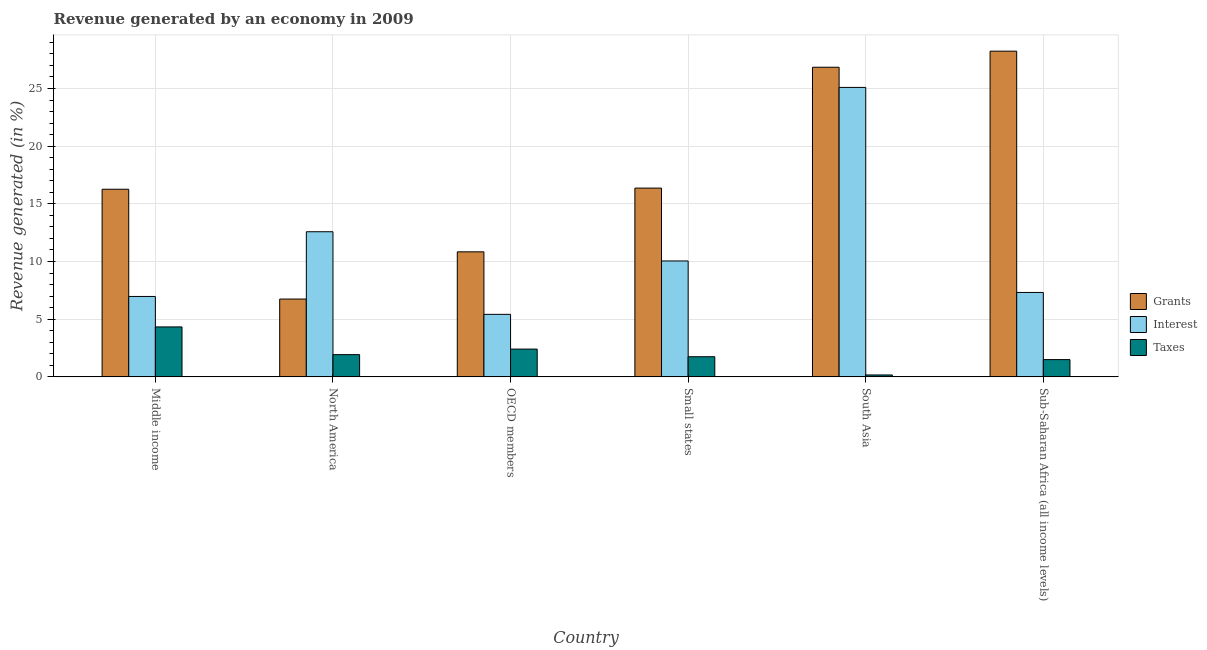How many different coloured bars are there?
Your response must be concise. 3. How many groups of bars are there?
Provide a short and direct response. 6. Are the number of bars on each tick of the X-axis equal?
Make the answer very short. Yes. What is the percentage of revenue generated by grants in Sub-Saharan Africa (all income levels)?
Your answer should be very brief. 28.24. Across all countries, what is the maximum percentage of revenue generated by taxes?
Offer a terse response. 4.33. Across all countries, what is the minimum percentage of revenue generated by grants?
Keep it short and to the point. 6.75. What is the total percentage of revenue generated by taxes in the graph?
Your response must be concise. 12.08. What is the difference between the percentage of revenue generated by grants in South Asia and that in Sub-Saharan Africa (all income levels)?
Ensure brevity in your answer.  -1.39. What is the difference between the percentage of revenue generated by grants in OECD members and the percentage of revenue generated by interest in South Asia?
Your answer should be very brief. -14.26. What is the average percentage of revenue generated by interest per country?
Your answer should be very brief. 11.24. What is the difference between the percentage of revenue generated by taxes and percentage of revenue generated by interest in North America?
Provide a succinct answer. -10.65. What is the ratio of the percentage of revenue generated by taxes in Middle income to that in Sub-Saharan Africa (all income levels)?
Offer a very short reply. 2.89. Is the difference between the percentage of revenue generated by grants in Small states and Sub-Saharan Africa (all income levels) greater than the difference between the percentage of revenue generated by interest in Small states and Sub-Saharan Africa (all income levels)?
Your answer should be very brief. No. What is the difference between the highest and the second highest percentage of revenue generated by interest?
Your answer should be compact. 12.51. What is the difference between the highest and the lowest percentage of revenue generated by grants?
Your answer should be compact. 21.49. In how many countries, is the percentage of revenue generated by taxes greater than the average percentage of revenue generated by taxes taken over all countries?
Keep it short and to the point. 2. Is the sum of the percentage of revenue generated by taxes in Small states and South Asia greater than the maximum percentage of revenue generated by grants across all countries?
Give a very brief answer. No. What does the 3rd bar from the left in Sub-Saharan Africa (all income levels) represents?
Your response must be concise. Taxes. What does the 3rd bar from the right in Middle income represents?
Give a very brief answer. Grants. How many bars are there?
Your answer should be very brief. 18. Are all the bars in the graph horizontal?
Provide a short and direct response. No. What is the difference between two consecutive major ticks on the Y-axis?
Offer a very short reply. 5. Does the graph contain any zero values?
Offer a very short reply. No. How many legend labels are there?
Offer a terse response. 3. How are the legend labels stacked?
Your answer should be very brief. Vertical. What is the title of the graph?
Ensure brevity in your answer.  Revenue generated by an economy in 2009. What is the label or title of the X-axis?
Keep it short and to the point. Country. What is the label or title of the Y-axis?
Your response must be concise. Revenue generated (in %). What is the Revenue generated (in %) of Grants in Middle income?
Offer a terse response. 16.27. What is the Revenue generated (in %) in Interest in Middle income?
Your answer should be compact. 6.97. What is the Revenue generated (in %) of Taxes in Middle income?
Offer a terse response. 4.33. What is the Revenue generated (in %) of Grants in North America?
Your answer should be very brief. 6.75. What is the Revenue generated (in %) in Interest in North America?
Offer a very short reply. 12.58. What is the Revenue generated (in %) in Taxes in North America?
Keep it short and to the point. 1.93. What is the Revenue generated (in %) of Grants in OECD members?
Your answer should be very brief. 10.84. What is the Revenue generated (in %) in Interest in OECD members?
Give a very brief answer. 5.42. What is the Revenue generated (in %) in Taxes in OECD members?
Offer a terse response. 2.41. What is the Revenue generated (in %) in Grants in Small states?
Your response must be concise. 16.37. What is the Revenue generated (in %) of Interest in Small states?
Your response must be concise. 10.05. What is the Revenue generated (in %) in Taxes in Small states?
Keep it short and to the point. 1.75. What is the Revenue generated (in %) of Grants in South Asia?
Provide a short and direct response. 26.84. What is the Revenue generated (in %) of Interest in South Asia?
Offer a very short reply. 25.1. What is the Revenue generated (in %) in Taxes in South Asia?
Your answer should be very brief. 0.17. What is the Revenue generated (in %) in Grants in Sub-Saharan Africa (all income levels)?
Offer a very short reply. 28.24. What is the Revenue generated (in %) in Interest in Sub-Saharan Africa (all income levels)?
Offer a very short reply. 7.32. What is the Revenue generated (in %) in Taxes in Sub-Saharan Africa (all income levels)?
Give a very brief answer. 1.5. Across all countries, what is the maximum Revenue generated (in %) in Grants?
Your answer should be very brief. 28.24. Across all countries, what is the maximum Revenue generated (in %) of Interest?
Offer a very short reply. 25.1. Across all countries, what is the maximum Revenue generated (in %) of Taxes?
Your answer should be very brief. 4.33. Across all countries, what is the minimum Revenue generated (in %) in Grants?
Make the answer very short. 6.75. Across all countries, what is the minimum Revenue generated (in %) of Interest?
Provide a short and direct response. 5.42. Across all countries, what is the minimum Revenue generated (in %) of Taxes?
Offer a terse response. 0.17. What is the total Revenue generated (in %) of Grants in the graph?
Offer a very short reply. 105.3. What is the total Revenue generated (in %) in Interest in the graph?
Make the answer very short. 67.44. What is the total Revenue generated (in %) in Taxes in the graph?
Ensure brevity in your answer.  12.08. What is the difference between the Revenue generated (in %) of Grants in Middle income and that in North America?
Your answer should be compact. 9.52. What is the difference between the Revenue generated (in %) in Interest in Middle income and that in North America?
Offer a very short reply. -5.61. What is the difference between the Revenue generated (in %) of Taxes in Middle income and that in North America?
Ensure brevity in your answer.  2.4. What is the difference between the Revenue generated (in %) of Grants in Middle income and that in OECD members?
Provide a short and direct response. 5.43. What is the difference between the Revenue generated (in %) in Interest in Middle income and that in OECD members?
Your answer should be very brief. 1.55. What is the difference between the Revenue generated (in %) in Taxes in Middle income and that in OECD members?
Your answer should be compact. 1.92. What is the difference between the Revenue generated (in %) of Grants in Middle income and that in Small states?
Offer a terse response. -0.1. What is the difference between the Revenue generated (in %) of Interest in Middle income and that in Small states?
Your answer should be compact. -3.08. What is the difference between the Revenue generated (in %) in Taxes in Middle income and that in Small states?
Provide a succinct answer. 2.58. What is the difference between the Revenue generated (in %) in Grants in Middle income and that in South Asia?
Ensure brevity in your answer.  -10.58. What is the difference between the Revenue generated (in %) in Interest in Middle income and that in South Asia?
Make the answer very short. -18.12. What is the difference between the Revenue generated (in %) of Taxes in Middle income and that in South Asia?
Offer a very short reply. 4.17. What is the difference between the Revenue generated (in %) of Grants in Middle income and that in Sub-Saharan Africa (all income levels)?
Offer a terse response. -11.97. What is the difference between the Revenue generated (in %) in Interest in Middle income and that in Sub-Saharan Africa (all income levels)?
Provide a short and direct response. -0.35. What is the difference between the Revenue generated (in %) in Taxes in Middle income and that in Sub-Saharan Africa (all income levels)?
Offer a very short reply. 2.83. What is the difference between the Revenue generated (in %) of Grants in North America and that in OECD members?
Your answer should be compact. -4.09. What is the difference between the Revenue generated (in %) in Interest in North America and that in OECD members?
Ensure brevity in your answer.  7.16. What is the difference between the Revenue generated (in %) of Taxes in North America and that in OECD members?
Your answer should be very brief. -0.48. What is the difference between the Revenue generated (in %) of Grants in North America and that in Small states?
Provide a short and direct response. -9.62. What is the difference between the Revenue generated (in %) of Interest in North America and that in Small states?
Keep it short and to the point. 2.53. What is the difference between the Revenue generated (in %) in Taxes in North America and that in Small states?
Provide a succinct answer. 0.18. What is the difference between the Revenue generated (in %) in Grants in North America and that in South Asia?
Make the answer very short. -20.1. What is the difference between the Revenue generated (in %) of Interest in North America and that in South Asia?
Provide a succinct answer. -12.51. What is the difference between the Revenue generated (in %) of Taxes in North America and that in South Asia?
Provide a succinct answer. 1.76. What is the difference between the Revenue generated (in %) in Grants in North America and that in Sub-Saharan Africa (all income levels)?
Provide a short and direct response. -21.49. What is the difference between the Revenue generated (in %) in Interest in North America and that in Sub-Saharan Africa (all income levels)?
Keep it short and to the point. 5.26. What is the difference between the Revenue generated (in %) in Taxes in North America and that in Sub-Saharan Africa (all income levels)?
Your response must be concise. 0.43. What is the difference between the Revenue generated (in %) of Grants in OECD members and that in Small states?
Ensure brevity in your answer.  -5.53. What is the difference between the Revenue generated (in %) in Interest in OECD members and that in Small states?
Provide a short and direct response. -4.63. What is the difference between the Revenue generated (in %) in Taxes in OECD members and that in Small states?
Provide a succinct answer. 0.66. What is the difference between the Revenue generated (in %) of Grants in OECD members and that in South Asia?
Your response must be concise. -16. What is the difference between the Revenue generated (in %) in Interest in OECD members and that in South Asia?
Offer a very short reply. -19.68. What is the difference between the Revenue generated (in %) of Taxes in OECD members and that in South Asia?
Your answer should be very brief. 2.24. What is the difference between the Revenue generated (in %) in Grants in OECD members and that in Sub-Saharan Africa (all income levels)?
Give a very brief answer. -17.4. What is the difference between the Revenue generated (in %) in Interest in OECD members and that in Sub-Saharan Africa (all income levels)?
Make the answer very short. -1.9. What is the difference between the Revenue generated (in %) of Taxes in OECD members and that in Sub-Saharan Africa (all income levels)?
Keep it short and to the point. 0.91. What is the difference between the Revenue generated (in %) of Grants in Small states and that in South Asia?
Your response must be concise. -10.48. What is the difference between the Revenue generated (in %) of Interest in Small states and that in South Asia?
Offer a terse response. -15.05. What is the difference between the Revenue generated (in %) of Taxes in Small states and that in South Asia?
Provide a short and direct response. 1.58. What is the difference between the Revenue generated (in %) of Grants in Small states and that in Sub-Saharan Africa (all income levels)?
Make the answer very short. -11.87. What is the difference between the Revenue generated (in %) of Interest in Small states and that in Sub-Saharan Africa (all income levels)?
Provide a succinct answer. 2.73. What is the difference between the Revenue generated (in %) of Taxes in Small states and that in Sub-Saharan Africa (all income levels)?
Give a very brief answer. 0.25. What is the difference between the Revenue generated (in %) in Grants in South Asia and that in Sub-Saharan Africa (all income levels)?
Provide a succinct answer. -1.39. What is the difference between the Revenue generated (in %) in Interest in South Asia and that in Sub-Saharan Africa (all income levels)?
Provide a short and direct response. 17.78. What is the difference between the Revenue generated (in %) in Taxes in South Asia and that in Sub-Saharan Africa (all income levels)?
Offer a terse response. -1.33. What is the difference between the Revenue generated (in %) of Grants in Middle income and the Revenue generated (in %) of Interest in North America?
Provide a succinct answer. 3.69. What is the difference between the Revenue generated (in %) in Grants in Middle income and the Revenue generated (in %) in Taxes in North America?
Keep it short and to the point. 14.34. What is the difference between the Revenue generated (in %) of Interest in Middle income and the Revenue generated (in %) of Taxes in North America?
Your answer should be compact. 5.04. What is the difference between the Revenue generated (in %) of Grants in Middle income and the Revenue generated (in %) of Interest in OECD members?
Your answer should be compact. 10.85. What is the difference between the Revenue generated (in %) in Grants in Middle income and the Revenue generated (in %) in Taxes in OECD members?
Your response must be concise. 13.86. What is the difference between the Revenue generated (in %) in Interest in Middle income and the Revenue generated (in %) in Taxes in OECD members?
Your answer should be very brief. 4.56. What is the difference between the Revenue generated (in %) of Grants in Middle income and the Revenue generated (in %) of Interest in Small states?
Your answer should be compact. 6.22. What is the difference between the Revenue generated (in %) of Grants in Middle income and the Revenue generated (in %) of Taxes in Small states?
Give a very brief answer. 14.52. What is the difference between the Revenue generated (in %) of Interest in Middle income and the Revenue generated (in %) of Taxes in Small states?
Ensure brevity in your answer.  5.23. What is the difference between the Revenue generated (in %) of Grants in Middle income and the Revenue generated (in %) of Interest in South Asia?
Ensure brevity in your answer.  -8.83. What is the difference between the Revenue generated (in %) of Grants in Middle income and the Revenue generated (in %) of Taxes in South Asia?
Ensure brevity in your answer.  16.1. What is the difference between the Revenue generated (in %) of Interest in Middle income and the Revenue generated (in %) of Taxes in South Asia?
Your answer should be compact. 6.81. What is the difference between the Revenue generated (in %) in Grants in Middle income and the Revenue generated (in %) in Interest in Sub-Saharan Africa (all income levels)?
Your response must be concise. 8.95. What is the difference between the Revenue generated (in %) in Grants in Middle income and the Revenue generated (in %) in Taxes in Sub-Saharan Africa (all income levels)?
Provide a short and direct response. 14.77. What is the difference between the Revenue generated (in %) in Interest in Middle income and the Revenue generated (in %) in Taxes in Sub-Saharan Africa (all income levels)?
Ensure brevity in your answer.  5.47. What is the difference between the Revenue generated (in %) in Grants in North America and the Revenue generated (in %) in Interest in OECD members?
Offer a terse response. 1.33. What is the difference between the Revenue generated (in %) in Grants in North America and the Revenue generated (in %) in Taxes in OECD members?
Provide a succinct answer. 4.34. What is the difference between the Revenue generated (in %) in Interest in North America and the Revenue generated (in %) in Taxes in OECD members?
Provide a short and direct response. 10.17. What is the difference between the Revenue generated (in %) of Grants in North America and the Revenue generated (in %) of Interest in Small states?
Your answer should be very brief. -3.3. What is the difference between the Revenue generated (in %) in Grants in North America and the Revenue generated (in %) in Taxes in Small states?
Offer a terse response. 5. What is the difference between the Revenue generated (in %) of Interest in North America and the Revenue generated (in %) of Taxes in Small states?
Your answer should be very brief. 10.84. What is the difference between the Revenue generated (in %) of Grants in North America and the Revenue generated (in %) of Interest in South Asia?
Offer a very short reply. -18.35. What is the difference between the Revenue generated (in %) of Grants in North America and the Revenue generated (in %) of Taxes in South Asia?
Provide a succinct answer. 6.58. What is the difference between the Revenue generated (in %) of Interest in North America and the Revenue generated (in %) of Taxes in South Asia?
Keep it short and to the point. 12.42. What is the difference between the Revenue generated (in %) in Grants in North America and the Revenue generated (in %) in Interest in Sub-Saharan Africa (all income levels)?
Your response must be concise. -0.57. What is the difference between the Revenue generated (in %) in Grants in North America and the Revenue generated (in %) in Taxes in Sub-Saharan Africa (all income levels)?
Provide a succinct answer. 5.25. What is the difference between the Revenue generated (in %) in Interest in North America and the Revenue generated (in %) in Taxes in Sub-Saharan Africa (all income levels)?
Ensure brevity in your answer.  11.08. What is the difference between the Revenue generated (in %) of Grants in OECD members and the Revenue generated (in %) of Interest in Small states?
Make the answer very short. 0.79. What is the difference between the Revenue generated (in %) in Grants in OECD members and the Revenue generated (in %) in Taxes in Small states?
Provide a short and direct response. 9.09. What is the difference between the Revenue generated (in %) in Interest in OECD members and the Revenue generated (in %) in Taxes in Small states?
Offer a very short reply. 3.67. What is the difference between the Revenue generated (in %) of Grants in OECD members and the Revenue generated (in %) of Interest in South Asia?
Make the answer very short. -14.26. What is the difference between the Revenue generated (in %) in Grants in OECD members and the Revenue generated (in %) in Taxes in South Asia?
Keep it short and to the point. 10.67. What is the difference between the Revenue generated (in %) in Interest in OECD members and the Revenue generated (in %) in Taxes in South Asia?
Give a very brief answer. 5.25. What is the difference between the Revenue generated (in %) in Grants in OECD members and the Revenue generated (in %) in Interest in Sub-Saharan Africa (all income levels)?
Offer a very short reply. 3.52. What is the difference between the Revenue generated (in %) of Grants in OECD members and the Revenue generated (in %) of Taxes in Sub-Saharan Africa (all income levels)?
Your response must be concise. 9.34. What is the difference between the Revenue generated (in %) in Interest in OECD members and the Revenue generated (in %) in Taxes in Sub-Saharan Africa (all income levels)?
Ensure brevity in your answer.  3.92. What is the difference between the Revenue generated (in %) of Grants in Small states and the Revenue generated (in %) of Interest in South Asia?
Give a very brief answer. -8.73. What is the difference between the Revenue generated (in %) in Grants in Small states and the Revenue generated (in %) in Taxes in South Asia?
Offer a very short reply. 16.2. What is the difference between the Revenue generated (in %) of Interest in Small states and the Revenue generated (in %) of Taxes in South Asia?
Offer a terse response. 9.88. What is the difference between the Revenue generated (in %) of Grants in Small states and the Revenue generated (in %) of Interest in Sub-Saharan Africa (all income levels)?
Provide a short and direct response. 9.05. What is the difference between the Revenue generated (in %) in Grants in Small states and the Revenue generated (in %) in Taxes in Sub-Saharan Africa (all income levels)?
Ensure brevity in your answer.  14.87. What is the difference between the Revenue generated (in %) in Interest in Small states and the Revenue generated (in %) in Taxes in Sub-Saharan Africa (all income levels)?
Make the answer very short. 8.55. What is the difference between the Revenue generated (in %) in Grants in South Asia and the Revenue generated (in %) in Interest in Sub-Saharan Africa (all income levels)?
Your answer should be compact. 19.53. What is the difference between the Revenue generated (in %) in Grants in South Asia and the Revenue generated (in %) in Taxes in Sub-Saharan Africa (all income levels)?
Your response must be concise. 25.35. What is the difference between the Revenue generated (in %) of Interest in South Asia and the Revenue generated (in %) of Taxes in Sub-Saharan Africa (all income levels)?
Provide a short and direct response. 23.6. What is the average Revenue generated (in %) in Grants per country?
Ensure brevity in your answer.  17.55. What is the average Revenue generated (in %) in Interest per country?
Provide a short and direct response. 11.24. What is the average Revenue generated (in %) of Taxes per country?
Your answer should be compact. 2.01. What is the difference between the Revenue generated (in %) of Grants and Revenue generated (in %) of Interest in Middle income?
Provide a succinct answer. 9.3. What is the difference between the Revenue generated (in %) in Grants and Revenue generated (in %) in Taxes in Middle income?
Keep it short and to the point. 11.94. What is the difference between the Revenue generated (in %) in Interest and Revenue generated (in %) in Taxes in Middle income?
Provide a succinct answer. 2.64. What is the difference between the Revenue generated (in %) in Grants and Revenue generated (in %) in Interest in North America?
Your response must be concise. -5.83. What is the difference between the Revenue generated (in %) in Grants and Revenue generated (in %) in Taxes in North America?
Ensure brevity in your answer.  4.82. What is the difference between the Revenue generated (in %) in Interest and Revenue generated (in %) in Taxes in North America?
Give a very brief answer. 10.65. What is the difference between the Revenue generated (in %) of Grants and Revenue generated (in %) of Interest in OECD members?
Keep it short and to the point. 5.42. What is the difference between the Revenue generated (in %) in Grants and Revenue generated (in %) in Taxes in OECD members?
Give a very brief answer. 8.43. What is the difference between the Revenue generated (in %) in Interest and Revenue generated (in %) in Taxes in OECD members?
Provide a succinct answer. 3.01. What is the difference between the Revenue generated (in %) in Grants and Revenue generated (in %) in Interest in Small states?
Offer a terse response. 6.32. What is the difference between the Revenue generated (in %) in Grants and Revenue generated (in %) in Taxes in Small states?
Make the answer very short. 14.62. What is the difference between the Revenue generated (in %) in Interest and Revenue generated (in %) in Taxes in Small states?
Give a very brief answer. 8.3. What is the difference between the Revenue generated (in %) of Grants and Revenue generated (in %) of Interest in South Asia?
Offer a very short reply. 1.75. What is the difference between the Revenue generated (in %) of Grants and Revenue generated (in %) of Taxes in South Asia?
Your response must be concise. 26.68. What is the difference between the Revenue generated (in %) in Interest and Revenue generated (in %) in Taxes in South Asia?
Make the answer very short. 24.93. What is the difference between the Revenue generated (in %) in Grants and Revenue generated (in %) in Interest in Sub-Saharan Africa (all income levels)?
Offer a terse response. 20.92. What is the difference between the Revenue generated (in %) in Grants and Revenue generated (in %) in Taxes in Sub-Saharan Africa (all income levels)?
Offer a very short reply. 26.74. What is the difference between the Revenue generated (in %) in Interest and Revenue generated (in %) in Taxes in Sub-Saharan Africa (all income levels)?
Provide a short and direct response. 5.82. What is the ratio of the Revenue generated (in %) of Grants in Middle income to that in North America?
Provide a short and direct response. 2.41. What is the ratio of the Revenue generated (in %) in Interest in Middle income to that in North America?
Make the answer very short. 0.55. What is the ratio of the Revenue generated (in %) of Taxes in Middle income to that in North America?
Provide a short and direct response. 2.25. What is the ratio of the Revenue generated (in %) in Grants in Middle income to that in OECD members?
Your answer should be compact. 1.5. What is the ratio of the Revenue generated (in %) of Interest in Middle income to that in OECD members?
Your answer should be very brief. 1.29. What is the ratio of the Revenue generated (in %) in Taxes in Middle income to that in OECD members?
Make the answer very short. 1.8. What is the ratio of the Revenue generated (in %) of Grants in Middle income to that in Small states?
Your answer should be compact. 0.99. What is the ratio of the Revenue generated (in %) in Interest in Middle income to that in Small states?
Ensure brevity in your answer.  0.69. What is the ratio of the Revenue generated (in %) of Taxes in Middle income to that in Small states?
Give a very brief answer. 2.48. What is the ratio of the Revenue generated (in %) in Grants in Middle income to that in South Asia?
Your response must be concise. 0.61. What is the ratio of the Revenue generated (in %) in Interest in Middle income to that in South Asia?
Your response must be concise. 0.28. What is the ratio of the Revenue generated (in %) in Taxes in Middle income to that in South Asia?
Your response must be concise. 26.06. What is the ratio of the Revenue generated (in %) in Grants in Middle income to that in Sub-Saharan Africa (all income levels)?
Your answer should be very brief. 0.58. What is the ratio of the Revenue generated (in %) in Interest in Middle income to that in Sub-Saharan Africa (all income levels)?
Keep it short and to the point. 0.95. What is the ratio of the Revenue generated (in %) of Taxes in Middle income to that in Sub-Saharan Africa (all income levels)?
Provide a succinct answer. 2.89. What is the ratio of the Revenue generated (in %) in Grants in North America to that in OECD members?
Provide a succinct answer. 0.62. What is the ratio of the Revenue generated (in %) in Interest in North America to that in OECD members?
Provide a succinct answer. 2.32. What is the ratio of the Revenue generated (in %) in Taxes in North America to that in OECD members?
Your answer should be compact. 0.8. What is the ratio of the Revenue generated (in %) of Grants in North America to that in Small states?
Your response must be concise. 0.41. What is the ratio of the Revenue generated (in %) of Interest in North America to that in Small states?
Ensure brevity in your answer.  1.25. What is the ratio of the Revenue generated (in %) in Taxes in North America to that in Small states?
Your answer should be compact. 1.1. What is the ratio of the Revenue generated (in %) of Grants in North America to that in South Asia?
Keep it short and to the point. 0.25. What is the ratio of the Revenue generated (in %) of Interest in North America to that in South Asia?
Ensure brevity in your answer.  0.5. What is the ratio of the Revenue generated (in %) in Taxes in North America to that in South Asia?
Your answer should be compact. 11.6. What is the ratio of the Revenue generated (in %) in Grants in North America to that in Sub-Saharan Africa (all income levels)?
Your response must be concise. 0.24. What is the ratio of the Revenue generated (in %) in Interest in North America to that in Sub-Saharan Africa (all income levels)?
Offer a very short reply. 1.72. What is the ratio of the Revenue generated (in %) in Taxes in North America to that in Sub-Saharan Africa (all income levels)?
Provide a short and direct response. 1.29. What is the ratio of the Revenue generated (in %) in Grants in OECD members to that in Small states?
Your answer should be compact. 0.66. What is the ratio of the Revenue generated (in %) in Interest in OECD members to that in Small states?
Your response must be concise. 0.54. What is the ratio of the Revenue generated (in %) in Taxes in OECD members to that in Small states?
Provide a succinct answer. 1.38. What is the ratio of the Revenue generated (in %) in Grants in OECD members to that in South Asia?
Offer a terse response. 0.4. What is the ratio of the Revenue generated (in %) in Interest in OECD members to that in South Asia?
Give a very brief answer. 0.22. What is the ratio of the Revenue generated (in %) of Taxes in OECD members to that in South Asia?
Make the answer very short. 14.49. What is the ratio of the Revenue generated (in %) of Grants in OECD members to that in Sub-Saharan Africa (all income levels)?
Give a very brief answer. 0.38. What is the ratio of the Revenue generated (in %) in Interest in OECD members to that in Sub-Saharan Africa (all income levels)?
Provide a succinct answer. 0.74. What is the ratio of the Revenue generated (in %) of Taxes in OECD members to that in Sub-Saharan Africa (all income levels)?
Provide a succinct answer. 1.61. What is the ratio of the Revenue generated (in %) of Grants in Small states to that in South Asia?
Make the answer very short. 0.61. What is the ratio of the Revenue generated (in %) of Interest in Small states to that in South Asia?
Ensure brevity in your answer.  0.4. What is the ratio of the Revenue generated (in %) of Taxes in Small states to that in South Asia?
Provide a succinct answer. 10.51. What is the ratio of the Revenue generated (in %) of Grants in Small states to that in Sub-Saharan Africa (all income levels)?
Offer a very short reply. 0.58. What is the ratio of the Revenue generated (in %) in Interest in Small states to that in Sub-Saharan Africa (all income levels)?
Your answer should be compact. 1.37. What is the ratio of the Revenue generated (in %) in Taxes in Small states to that in Sub-Saharan Africa (all income levels)?
Ensure brevity in your answer.  1.17. What is the ratio of the Revenue generated (in %) in Grants in South Asia to that in Sub-Saharan Africa (all income levels)?
Your answer should be compact. 0.95. What is the ratio of the Revenue generated (in %) of Interest in South Asia to that in Sub-Saharan Africa (all income levels)?
Provide a succinct answer. 3.43. What is the ratio of the Revenue generated (in %) in Taxes in South Asia to that in Sub-Saharan Africa (all income levels)?
Provide a succinct answer. 0.11. What is the difference between the highest and the second highest Revenue generated (in %) of Grants?
Offer a terse response. 1.39. What is the difference between the highest and the second highest Revenue generated (in %) in Interest?
Provide a succinct answer. 12.51. What is the difference between the highest and the second highest Revenue generated (in %) of Taxes?
Offer a terse response. 1.92. What is the difference between the highest and the lowest Revenue generated (in %) in Grants?
Keep it short and to the point. 21.49. What is the difference between the highest and the lowest Revenue generated (in %) of Interest?
Give a very brief answer. 19.68. What is the difference between the highest and the lowest Revenue generated (in %) of Taxes?
Make the answer very short. 4.17. 